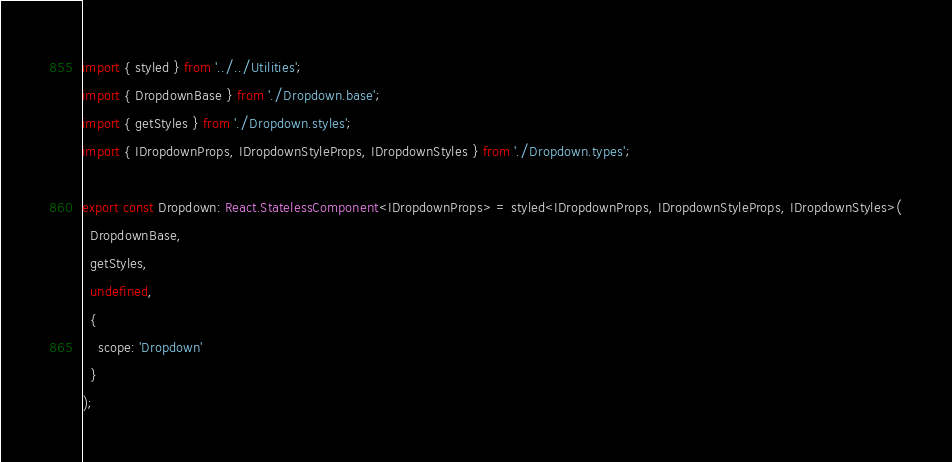<code> <loc_0><loc_0><loc_500><loc_500><_TypeScript_>import { styled } from '../../Utilities';
import { DropdownBase } from './Dropdown.base';
import { getStyles } from './Dropdown.styles';
import { IDropdownProps, IDropdownStyleProps, IDropdownStyles } from './Dropdown.types';

export const Dropdown: React.StatelessComponent<IDropdownProps> = styled<IDropdownProps, IDropdownStyleProps, IDropdownStyles>(
  DropdownBase,
  getStyles,
  undefined,
  {
    scope: 'Dropdown'
  }
);
</code> 